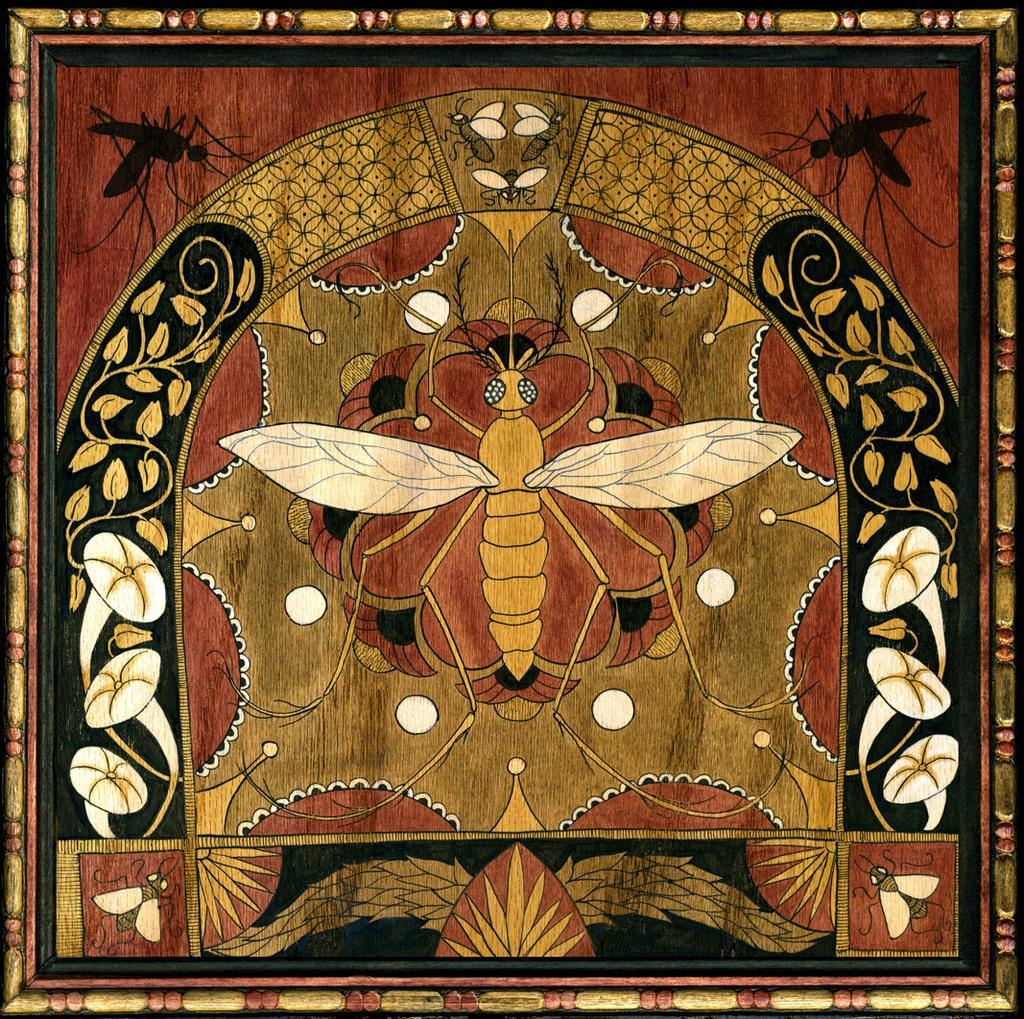Can you describe this image briefly? This is a painting in this image there are some insects, and some flowers. 